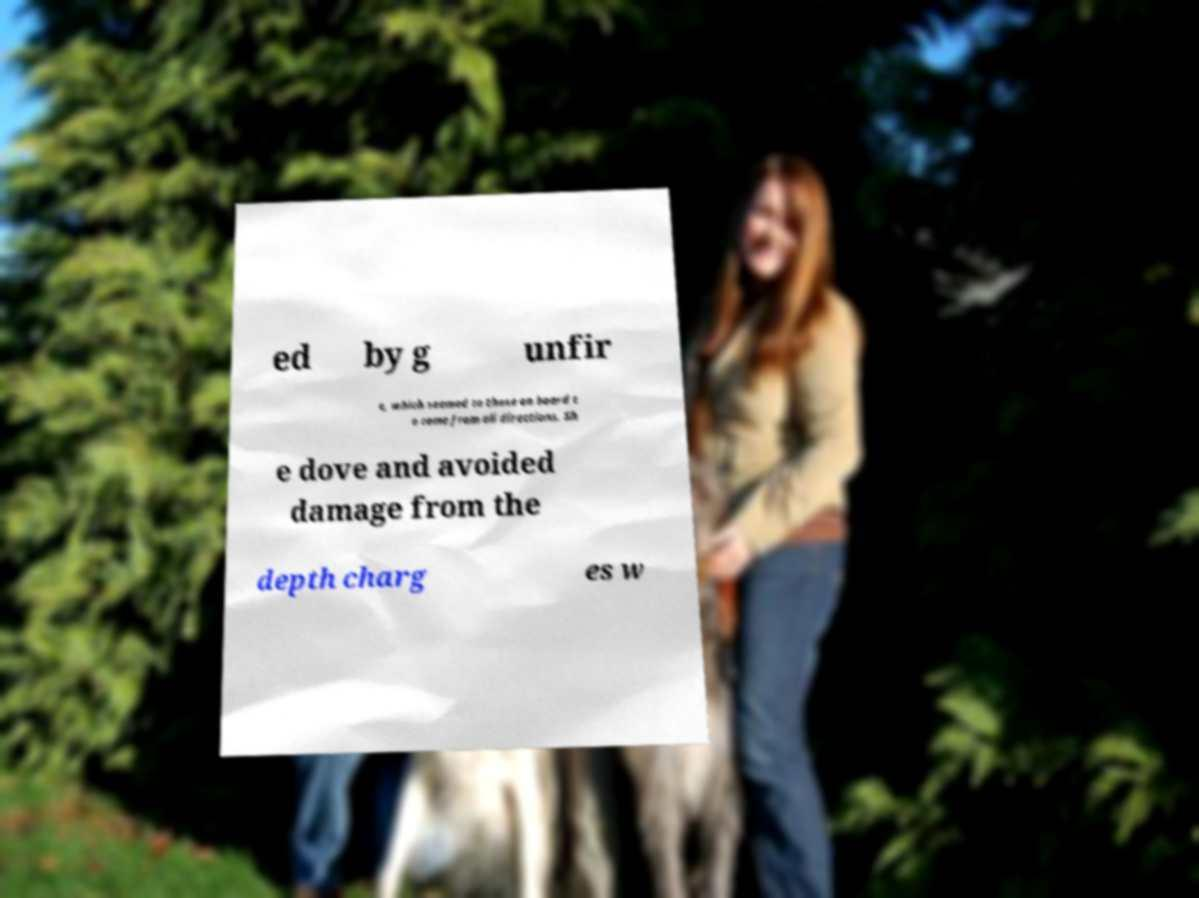Could you extract and type out the text from this image? ed by g unfir e, which seemed to those on board t o come from all directions. Sh e dove and avoided damage from the depth charg es w 